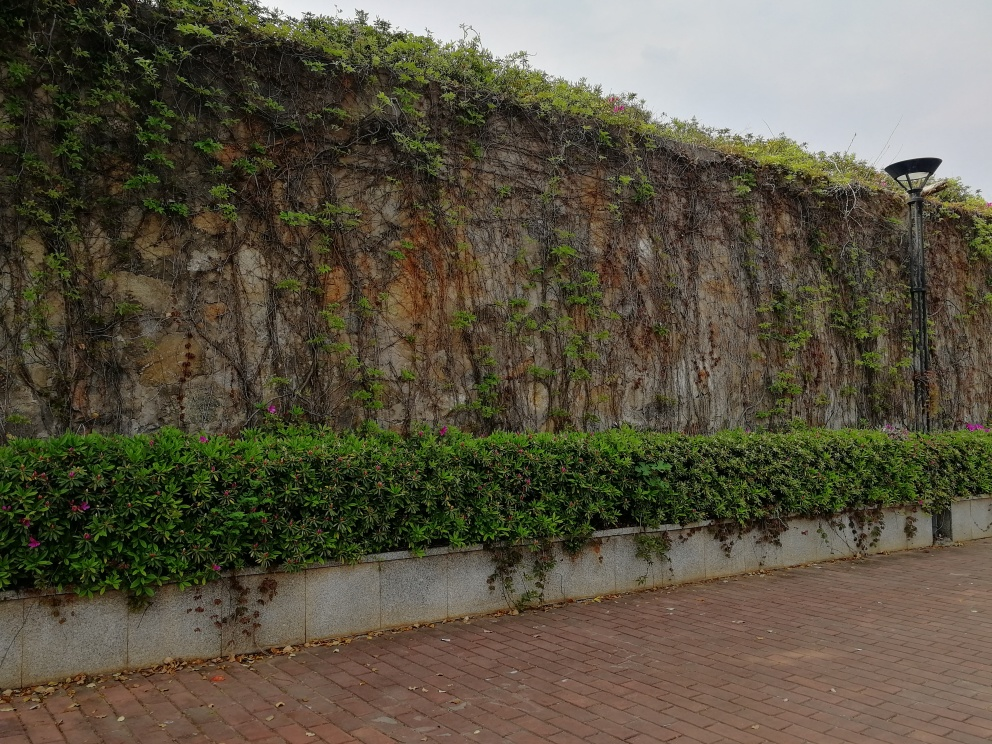Does the place in the image look well-maintained? The area seems to be fairly well-maintained. The hedge at the base is neatly trimmed, and the climbing plants on the wall are allowed to grow naturally, which is common for green walls to enhance aesthetics and biodiversity. The absence of litter or overgrowth onto the pavement further suggests regular maintenance. What benefits do such green walls provide to urban environments? Green walls, like the one depicted, offer several benefits to urban environments. They contribute to biodiversity by providing habitats for insects and birds. They can also improve air quality by filtering pollutants and producing oxygen. Aesthetically, they add natural beauty to urban landscapes, which can have a positive psychological impact on residents. Furthermore, green walls offer thermal insulation for buildings, reducing energy costs for heating and cooling. 